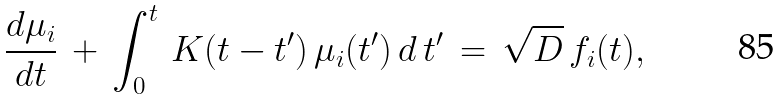Convert formula to latex. <formula><loc_0><loc_0><loc_500><loc_500>\frac { d \mu _ { i } } { d t } \, + \, \int _ { 0 } ^ { t } \, K ( t - t ^ { \prime } ) \, \mu _ { i } ( t ^ { \prime } ) \, d \, t ^ { \prime } \, = \, \sqrt { D } \, f _ { i } ( t ) ,</formula> 